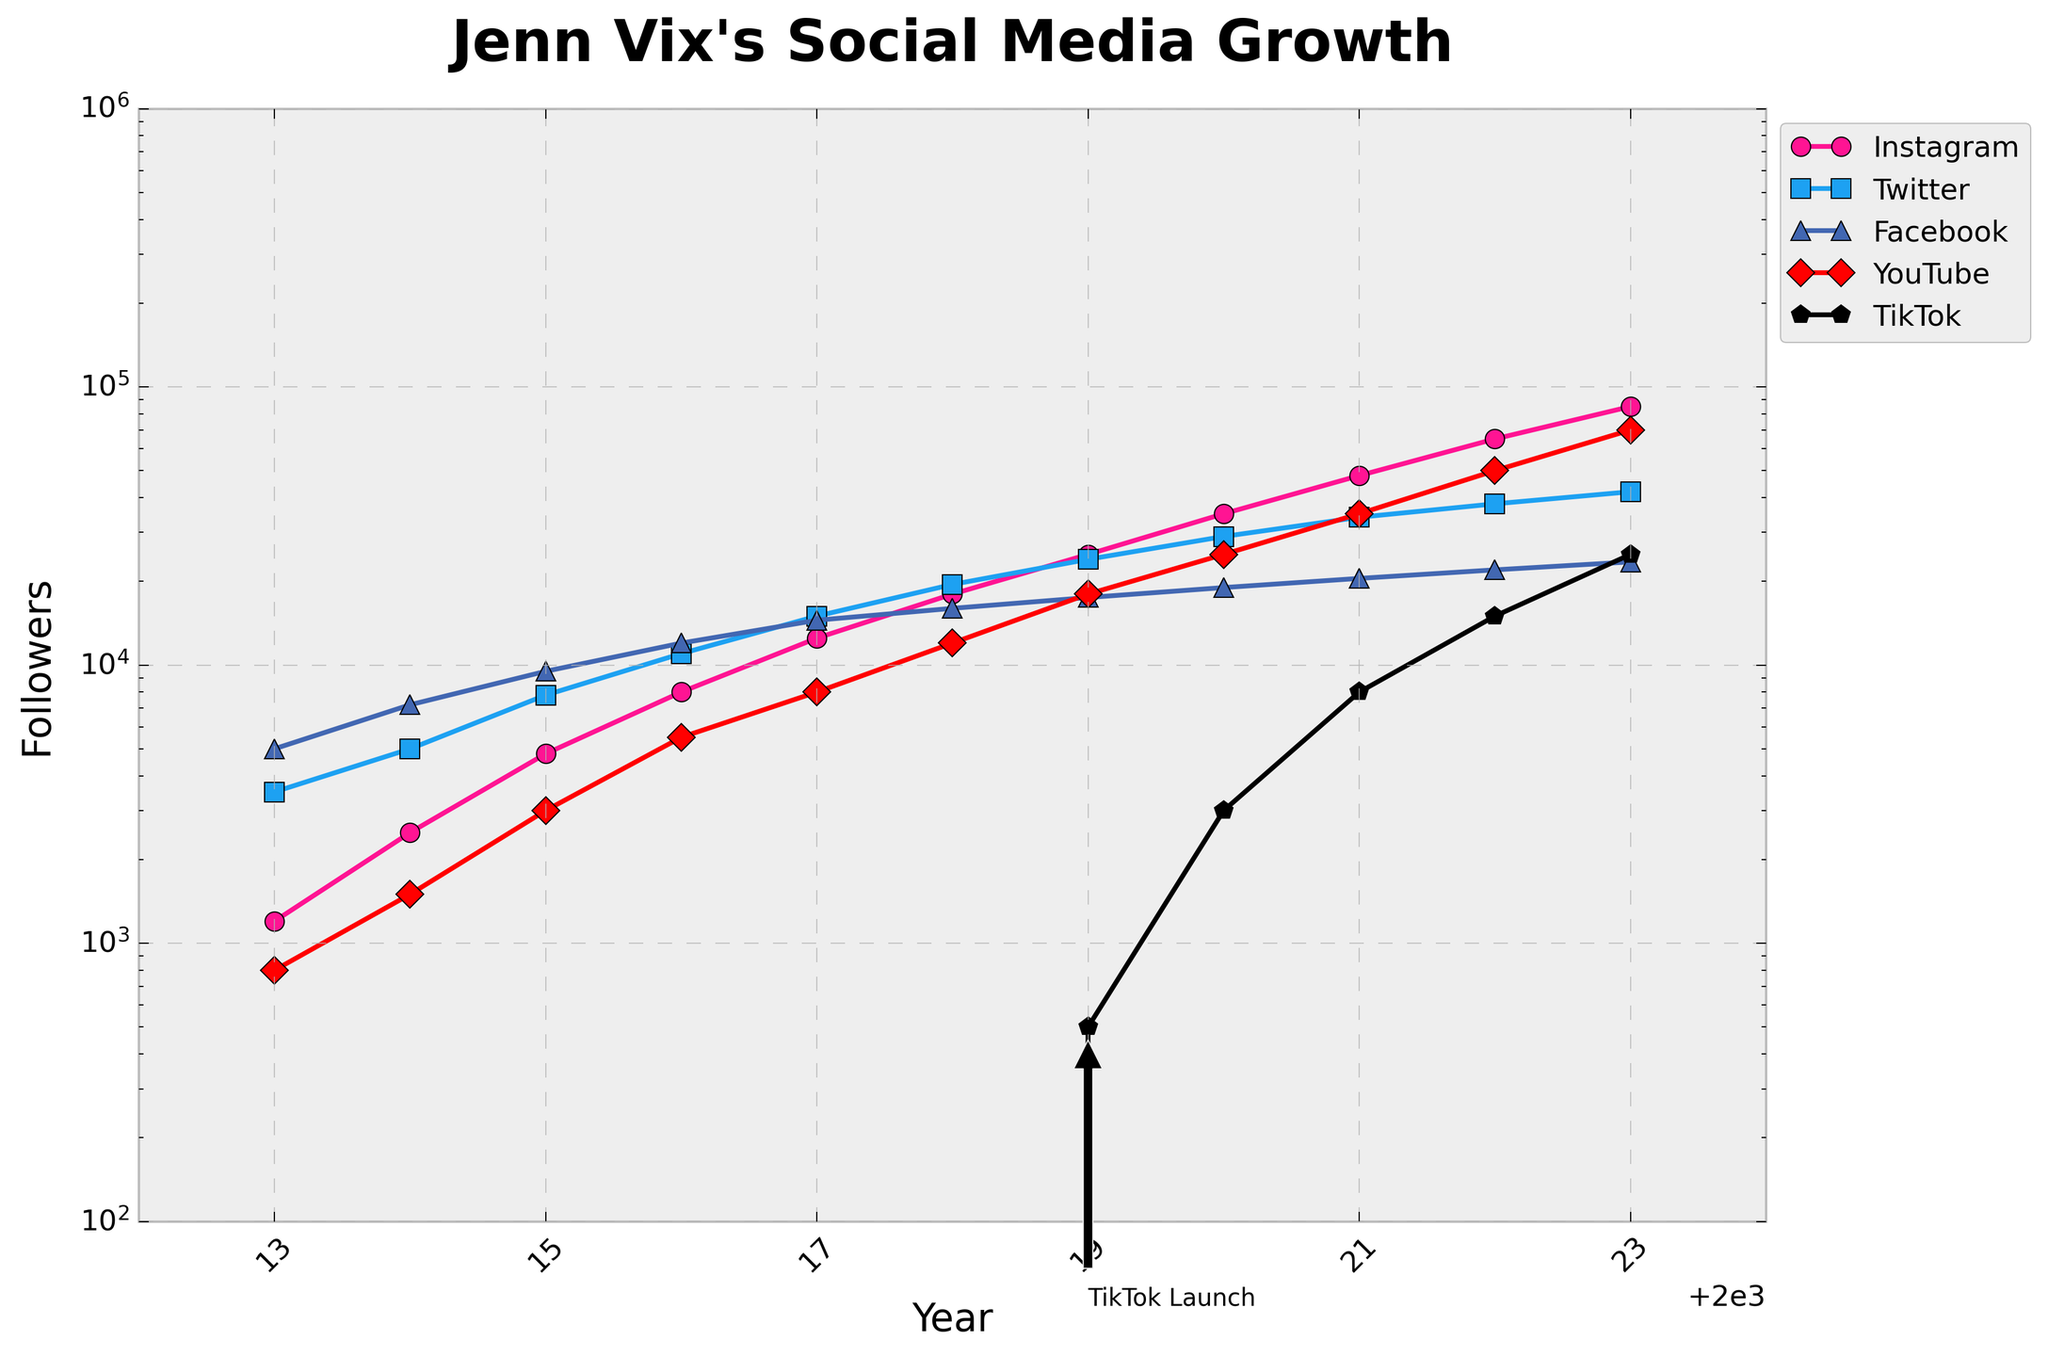What year did Jenn Vix start gaining followers on TikTok? From the figure, the TikTok line starts to appear and rise in 2019, indicating that Jenn Vix started gaining followers on TikTok that year.
Answer: 2019 Which platform had the highest number of followers in 2015? Looking at the figure for the year 2015, the platform with the highest line is Facebook, which had the highest number of followers that year.
Answer: Facebook Between which two consecutive years did Instagram see the highest increase in followers? Visually, the jump in the Instagram line is the highest between 2021 and 2022. Calculate the difference: 65000 (2022) - 48000 (2021) = 17000, which is the largest increase.
Answer: 2021 and 2022 How many followers did Jenn Vix have on YouTube in 2020? By locating the point on the YouTube line in the year 2020, it can be seen that Jenn Vix had 25000 followers on YouTube that year.
Answer: 25000 What is the difference in Twitter followers between 2016 and 2020? By checking the figure, Twitter followers in 2016 were 11000, and in 2020 they were 29000. The difference is 29000 - 11000 = 18000.
Answer: 18000 Which platform had the least number of followers in 2023? Referring to the plot for the year 2023, the platform with the lowest point is Facebook with 23500 followers.
Answer: Facebook What can be deduced about Jenn Vix's social media strategy from 2019 onwards, based on the figure? Jenn Vix started using TikTok in 2019 and saw significant growth there alongside a major increase in YouTube followers, suggesting a strategic pivot to these platforms.
Answer: Shift to TikTok and YouTube What was the average growth in Instagram followers per year from 2013 to 2023? Calculate the total increase in Instagram followers: 85000 - 1200 = 83800. Divide by the number of years: 83800 / (2023 - 2013) = 8380 followers per year.
Answer: 8380 per year 